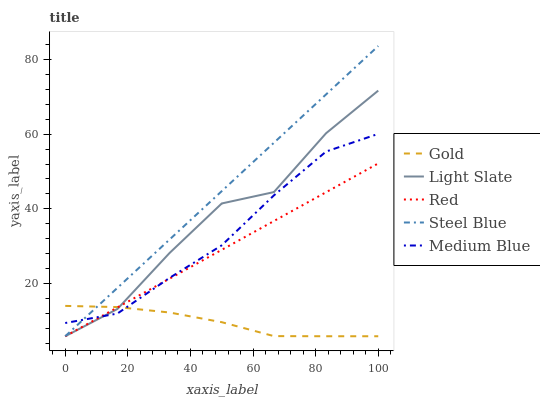Does Gold have the minimum area under the curve?
Answer yes or no. Yes. Does Steel Blue have the maximum area under the curve?
Answer yes or no. Yes. Does Medium Blue have the minimum area under the curve?
Answer yes or no. No. Does Medium Blue have the maximum area under the curve?
Answer yes or no. No. Is Red the smoothest?
Answer yes or no. Yes. Is Light Slate the roughest?
Answer yes or no. Yes. Is Medium Blue the smoothest?
Answer yes or no. No. Is Medium Blue the roughest?
Answer yes or no. No. Does Light Slate have the lowest value?
Answer yes or no. Yes. Does Medium Blue have the lowest value?
Answer yes or no. No. Does Steel Blue have the highest value?
Answer yes or no. Yes. Does Medium Blue have the highest value?
Answer yes or no. No. Does Steel Blue intersect Red?
Answer yes or no. Yes. Is Steel Blue less than Red?
Answer yes or no. No. Is Steel Blue greater than Red?
Answer yes or no. No. 